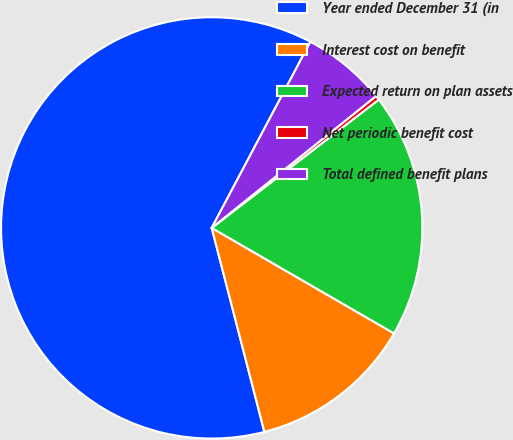<chart> <loc_0><loc_0><loc_500><loc_500><pie_chart><fcel>Year ended December 31 (in<fcel>Interest cost on benefit<fcel>Expected return on plan assets<fcel>Net periodic benefit cost<fcel>Total defined benefit plans<nl><fcel>61.78%<fcel>12.63%<fcel>18.77%<fcel>0.34%<fcel>6.48%<nl></chart> 